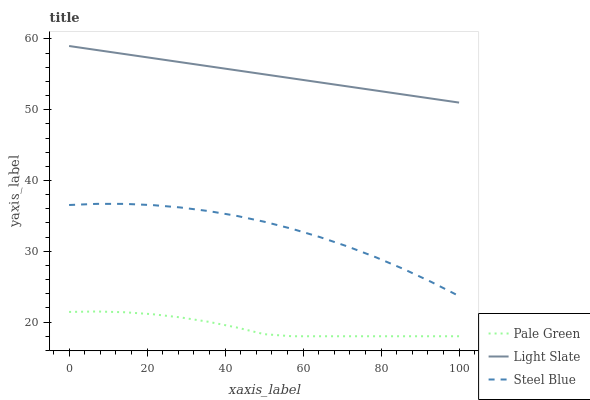Does Pale Green have the minimum area under the curve?
Answer yes or no. Yes. Does Light Slate have the maximum area under the curve?
Answer yes or no. Yes. Does Steel Blue have the minimum area under the curve?
Answer yes or no. No. Does Steel Blue have the maximum area under the curve?
Answer yes or no. No. Is Light Slate the smoothest?
Answer yes or no. Yes. Is Steel Blue the roughest?
Answer yes or no. Yes. Is Pale Green the smoothest?
Answer yes or no. No. Is Pale Green the roughest?
Answer yes or no. No. Does Pale Green have the lowest value?
Answer yes or no. Yes. Does Steel Blue have the lowest value?
Answer yes or no. No. Does Light Slate have the highest value?
Answer yes or no. Yes. Does Steel Blue have the highest value?
Answer yes or no. No. Is Pale Green less than Light Slate?
Answer yes or no. Yes. Is Light Slate greater than Pale Green?
Answer yes or no. Yes. Does Pale Green intersect Light Slate?
Answer yes or no. No. 